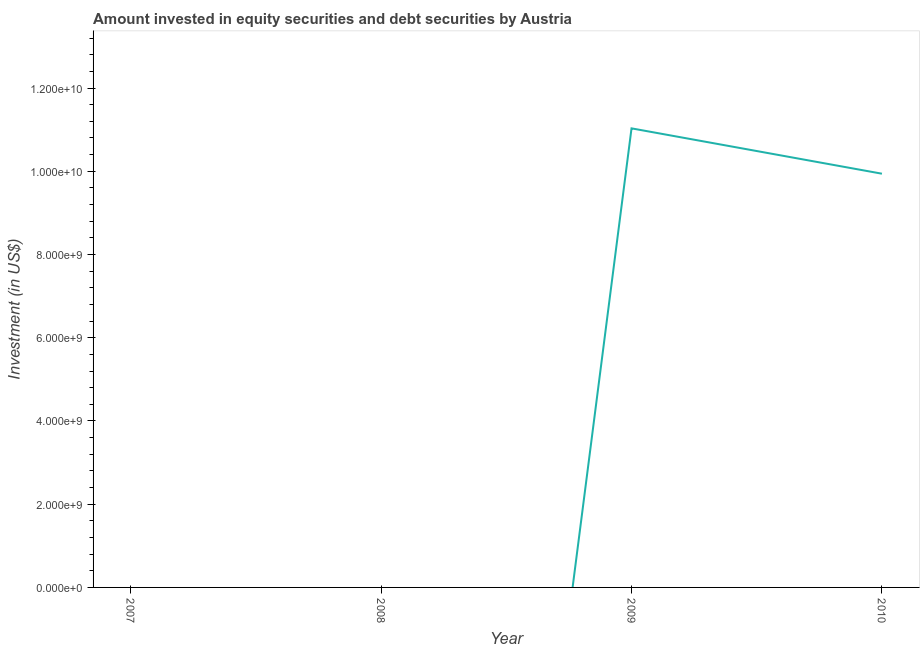What is the portfolio investment in 2010?
Give a very brief answer. 9.94e+09. Across all years, what is the maximum portfolio investment?
Your answer should be very brief. 1.10e+1. Across all years, what is the minimum portfolio investment?
Make the answer very short. 0. What is the sum of the portfolio investment?
Your response must be concise. 2.10e+1. What is the difference between the portfolio investment in 2009 and 2010?
Keep it short and to the point. 1.09e+09. What is the average portfolio investment per year?
Your response must be concise. 5.24e+09. What is the median portfolio investment?
Your answer should be very brief. 4.97e+09. Is the sum of the portfolio investment in 2009 and 2010 greater than the maximum portfolio investment across all years?
Offer a terse response. Yes. What is the difference between the highest and the lowest portfolio investment?
Provide a succinct answer. 1.10e+1. In how many years, is the portfolio investment greater than the average portfolio investment taken over all years?
Offer a very short reply. 2. Does the portfolio investment monotonically increase over the years?
Provide a short and direct response. No. How many lines are there?
Give a very brief answer. 1. What is the difference between two consecutive major ticks on the Y-axis?
Provide a succinct answer. 2.00e+09. Does the graph contain grids?
Your response must be concise. No. What is the title of the graph?
Your response must be concise. Amount invested in equity securities and debt securities by Austria. What is the label or title of the X-axis?
Keep it short and to the point. Year. What is the label or title of the Y-axis?
Provide a succinct answer. Investment (in US$). What is the Investment (in US$) in 2009?
Ensure brevity in your answer.  1.10e+1. What is the Investment (in US$) of 2010?
Offer a very short reply. 9.94e+09. What is the difference between the Investment (in US$) in 2009 and 2010?
Keep it short and to the point. 1.09e+09. What is the ratio of the Investment (in US$) in 2009 to that in 2010?
Ensure brevity in your answer.  1.11. 